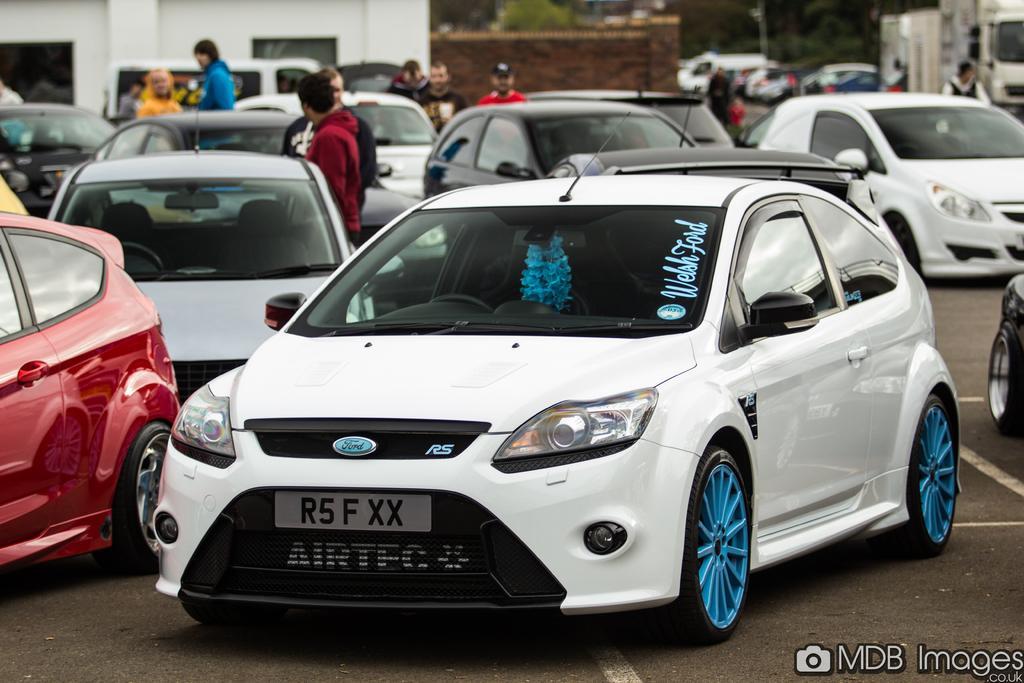In one or two sentences, can you explain what this image depicts? In this image we can see the vehicles on the road. In the background we can see some people, trees, building and also the fencing wall. In the bottom right corner we can see the text. 